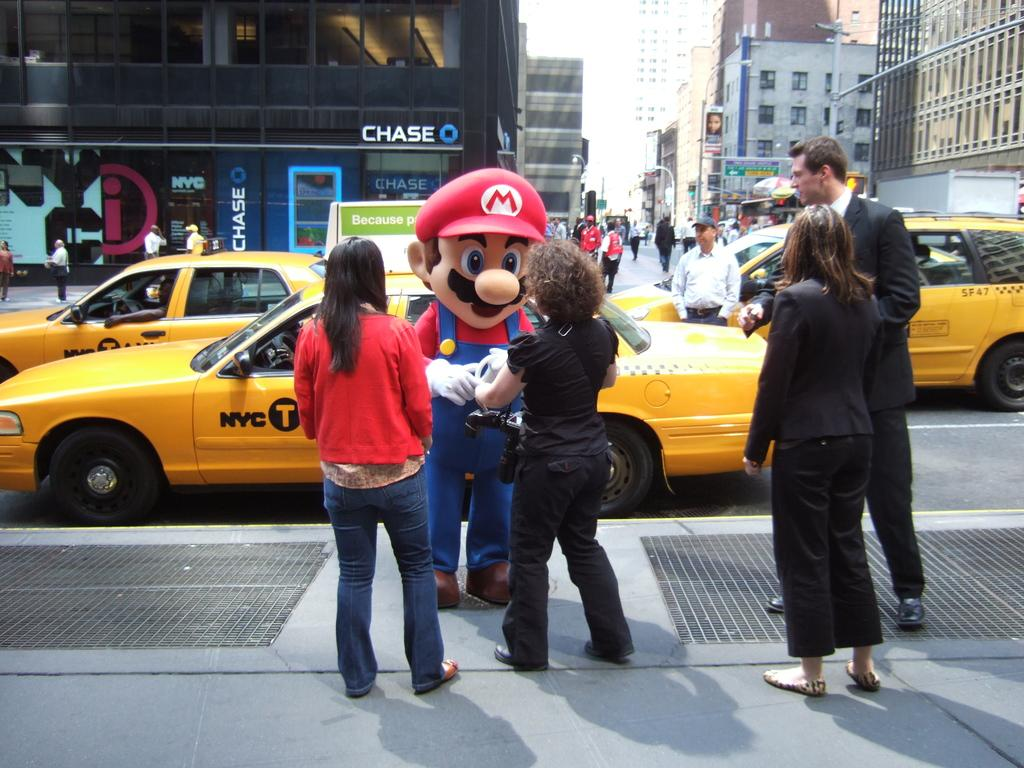<image>
Share a concise interpretation of the image provided. A costumed person stands on the corner with a Chase bank behind him. 